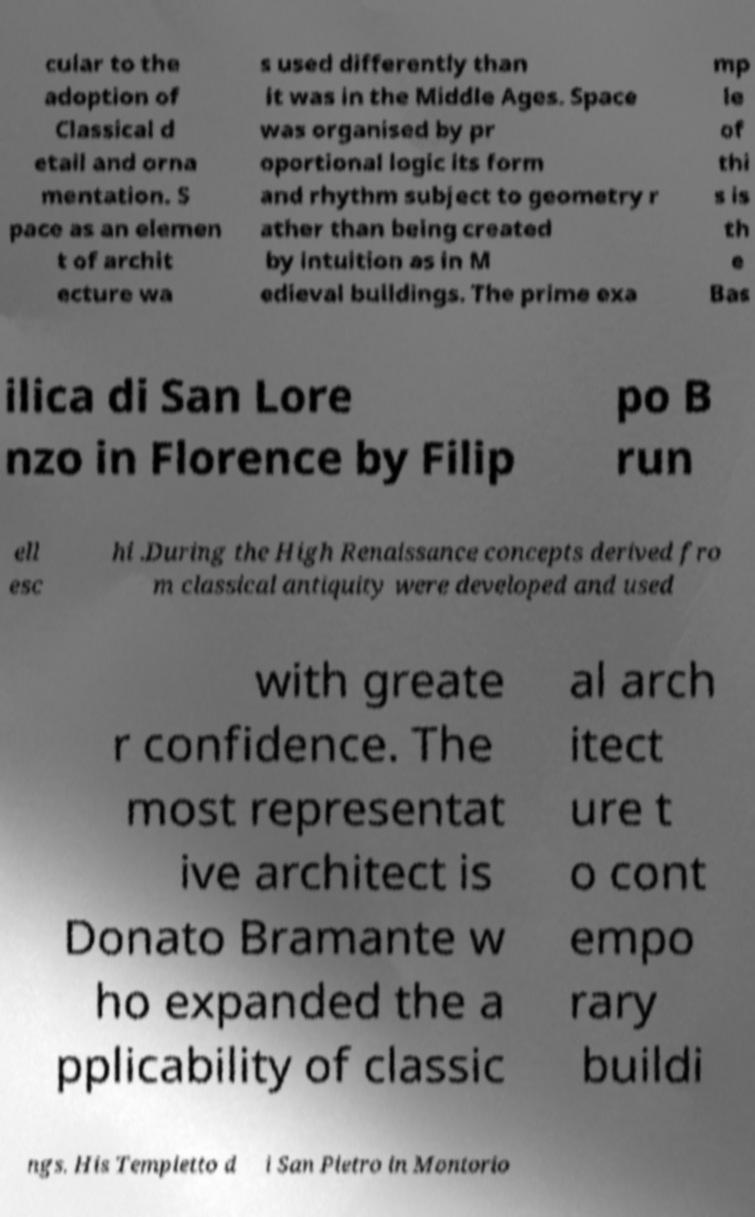Can you accurately transcribe the text from the provided image for me? cular to the adoption of Classical d etail and orna mentation. S pace as an elemen t of archit ecture wa s used differently than it was in the Middle Ages. Space was organised by pr oportional logic its form and rhythm subject to geometry r ather than being created by intuition as in M edieval buildings. The prime exa mp le of thi s is th e Bas ilica di San Lore nzo in Florence by Filip po B run ell esc hi .During the High Renaissance concepts derived fro m classical antiquity were developed and used with greate r confidence. The most representat ive architect is Donato Bramante w ho expanded the a pplicability of classic al arch itect ure t o cont empo rary buildi ngs. His Tempietto d i San Pietro in Montorio 